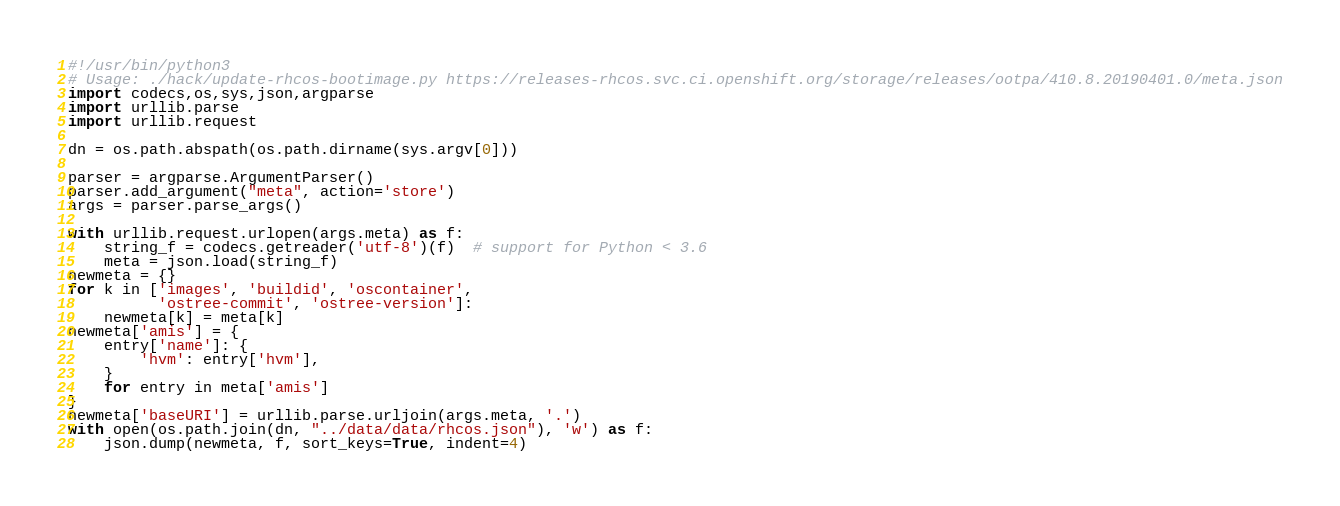Convert code to text. <code><loc_0><loc_0><loc_500><loc_500><_Python_>#!/usr/bin/python3
# Usage: ./hack/update-rhcos-bootimage.py https://releases-rhcos.svc.ci.openshift.org/storage/releases/ootpa/410.8.20190401.0/meta.json
import codecs,os,sys,json,argparse
import urllib.parse
import urllib.request

dn = os.path.abspath(os.path.dirname(sys.argv[0]))

parser = argparse.ArgumentParser()
parser.add_argument("meta", action='store')
args = parser.parse_args()

with urllib.request.urlopen(args.meta) as f:
    string_f = codecs.getreader('utf-8')(f)  # support for Python < 3.6
    meta = json.load(string_f)
newmeta = {}
for k in ['images', 'buildid', 'oscontainer',
          'ostree-commit', 'ostree-version']:
    newmeta[k] = meta[k]
newmeta['amis'] = {
    entry['name']: {
        'hvm': entry['hvm'],
    }
    for entry in meta['amis']
}
newmeta['baseURI'] = urllib.parse.urljoin(args.meta, '.')
with open(os.path.join(dn, "../data/data/rhcos.json"), 'w') as f:
    json.dump(newmeta, f, sort_keys=True, indent=4)
</code> 